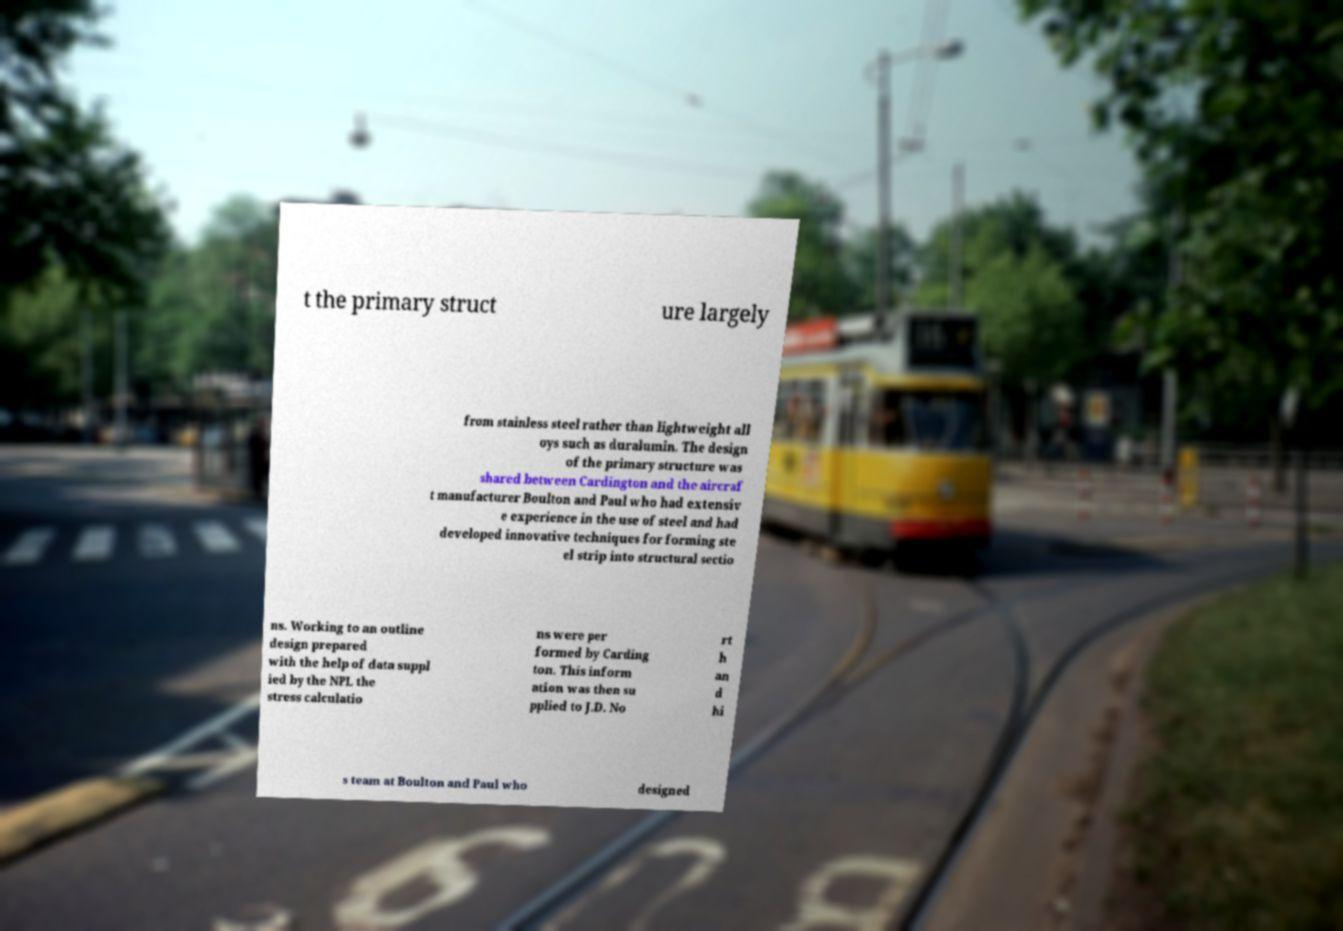Please identify and transcribe the text found in this image. t the primary struct ure largely from stainless steel rather than lightweight all oys such as duralumin. The design of the primary structure was shared between Cardington and the aircraf t manufacturer Boulton and Paul who had extensiv e experience in the use of steel and had developed innovative techniques for forming ste el strip into structural sectio ns. Working to an outline design prepared with the help of data suppl ied by the NPL the stress calculatio ns were per formed by Carding ton. This inform ation was then su pplied to J.D. No rt h an d hi s team at Boulton and Paul who designed 